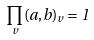<formula> <loc_0><loc_0><loc_500><loc_500>\prod _ { v } ( a , b ) _ { v } = 1</formula> 